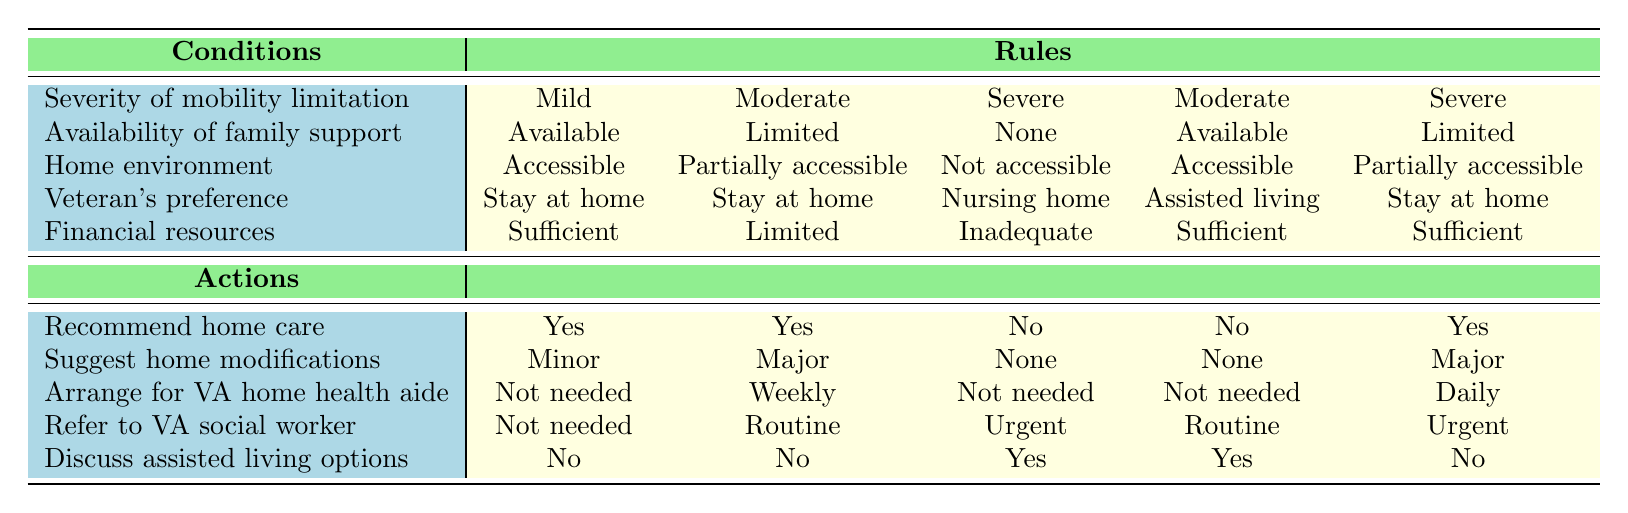What is the action for a veteran with moderate mobility limitations and limited family support? To find the action based on the conditions specified, locate the row that corresponds to "Moderate" mobility limitations and "Limited" family support. In the table, this matches column 2. The actions listed are: Recommend home care = Yes, Suggest home modifications = Major, Arrange for VA home health aide = Weekly, Refer to VA social worker = Routine, Discuss assisted living options = No.
Answer: Yes Is there a recommendation for home care when the veteran has severe mobility limitations and no family support? Check the row for "Severe" mobility limitations and "None" for family support. In that scenario, the action 'Recommend home care' is listed as No.
Answer: No What modifications are suggested for veterans preferring to stay at home with severe mobility limitations and limited family support? Look for the combination of "Stay at home" preference, "Severe" mobility limitation, and "Limited" family support. The corresponding row indicates that the suggested home modifications are Major.
Answer: Major How many actions involve recommending home care for veterans with sufficient financial resources? First, identify the rows where financial resources are "Sufficient" and count those instances where 'Recommend home care' is Yes. The first and fourth rows meet this criteria: Row 1 (Mild) and Row 4 (Moderate). Therefore, there are two actions that recommend home care with sufficient resources.
Answer: Two If a veteran has mild mobility limitations and sufficient financial resources, will they need a home health aide? Analyze the row for "Mild" mobility limitations and "Sufficient" financial resources. According to the table, the action 'Arrange for VA home health aide' is listed as Not needed.
Answer: Not needed What is the difference between the number of veterans who would prefer assisted living and those preferring to stay at home under the condition of moderate mobility limitations? In the case of moderate mobility limitations (second and fourth rules), both have "Stay at home" preference (No need to discuss assisted living) while both have Available and Limited family support respectively. The result shows 0 veterans preferring assisted living compared to those wanting to stay at home.
Answer: None Would a veteran in a fully accessible home with severe mobility limitations and inadequate financial resources be referred to a VA social worker? Find the row that fits "Severe" mobility limitations, "Not accessible" home environment, and "Inadequate" financial resources. The table indicates that the action for referring to a VA social worker is Urgent; therefore, the answer is yes.
Answer: Yes Is there a rule that suggests discussing assisted living for veterans with sufficient financial resources? Review the rows that indicate "Sufficient" financial resources. In the rows for moderate and mild conditions, the indication is No for discussing assisted living, confirming that these groups do not discuss that option under sufficient resources.
Answer: No What actions are recommended for a severely mobility-limited veteran living in an accessible home and preferring assisted living, with limited family support? Identify the conditions: "Severe" mobility limitations, "Accessible" home, and "Assisted living" preference. This coincides with Row 4 results: 'Recommend home care' is No, 'Suggest home modifications' is None, 'Arrange for VA home health aide' is Not needed, and 'Refer to VA social worker' is Routine, leading to that conclusion on recommendations.
Answer: No, None, Not needed, Routine 